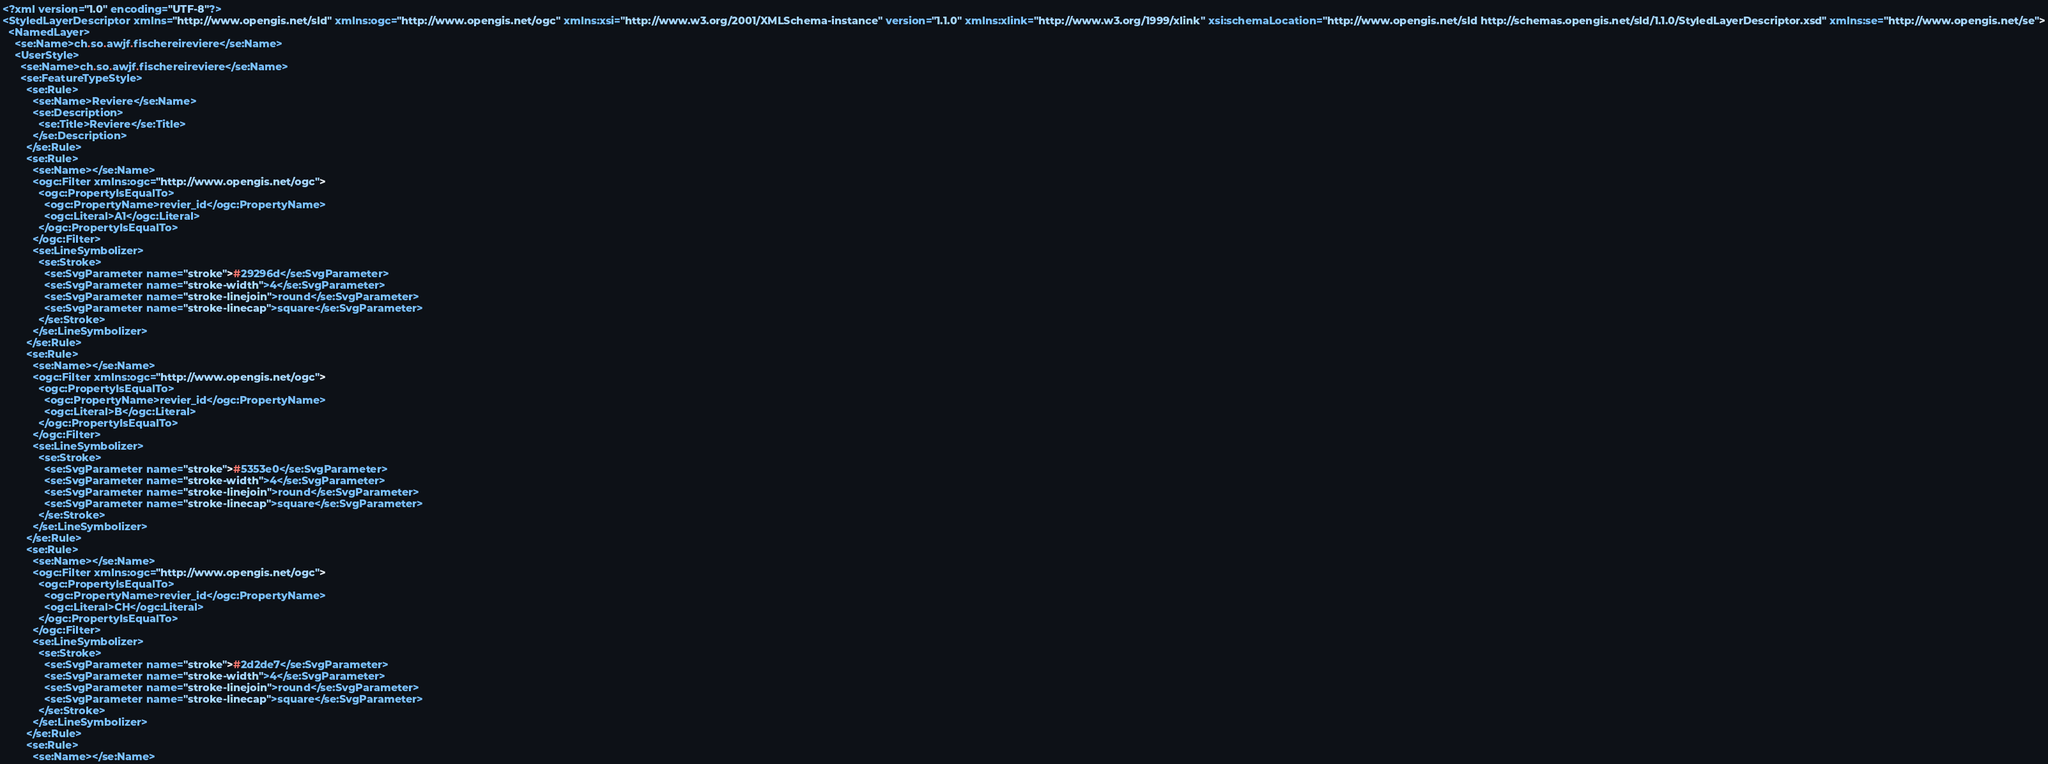<code> <loc_0><loc_0><loc_500><loc_500><_Scheme_><?xml version="1.0" encoding="UTF-8"?>
<StyledLayerDescriptor xmlns="http://www.opengis.net/sld" xmlns:ogc="http://www.opengis.net/ogc" xmlns:xsi="http://www.w3.org/2001/XMLSchema-instance" version="1.1.0" xmlns:xlink="http://www.w3.org/1999/xlink" xsi:schemaLocation="http://www.opengis.net/sld http://schemas.opengis.net/sld/1.1.0/StyledLayerDescriptor.xsd" xmlns:se="http://www.opengis.net/se">
  <NamedLayer>
    <se:Name>ch.so.awjf.fischereireviere</se:Name>
    <UserStyle>
      <se:Name>ch.so.awjf.fischereireviere</se:Name>
      <se:FeatureTypeStyle>
        <se:Rule>
          <se:Name>Reviere</se:Name>
          <se:Description>
            <se:Title>Reviere</se:Title>
          </se:Description>
        </se:Rule>
        <se:Rule>
          <se:Name></se:Name>
          <ogc:Filter xmlns:ogc="http://www.opengis.net/ogc">
            <ogc:PropertyIsEqualTo>
              <ogc:PropertyName>revier_id</ogc:PropertyName>
              <ogc:Literal>A1</ogc:Literal>
            </ogc:PropertyIsEqualTo>
          </ogc:Filter>
          <se:LineSymbolizer>
            <se:Stroke>
              <se:SvgParameter name="stroke">#29296d</se:SvgParameter>
              <se:SvgParameter name="stroke-width">4</se:SvgParameter>
              <se:SvgParameter name="stroke-linejoin">round</se:SvgParameter>
              <se:SvgParameter name="stroke-linecap">square</se:SvgParameter>
            </se:Stroke>
          </se:LineSymbolizer>
        </se:Rule>
        <se:Rule>
          <se:Name></se:Name>
          <ogc:Filter xmlns:ogc="http://www.opengis.net/ogc">
            <ogc:PropertyIsEqualTo>
              <ogc:PropertyName>revier_id</ogc:PropertyName>
              <ogc:Literal>B</ogc:Literal>
            </ogc:PropertyIsEqualTo>
          </ogc:Filter>
          <se:LineSymbolizer>
            <se:Stroke>
              <se:SvgParameter name="stroke">#5353e0</se:SvgParameter>
              <se:SvgParameter name="stroke-width">4</se:SvgParameter>
              <se:SvgParameter name="stroke-linejoin">round</se:SvgParameter>
              <se:SvgParameter name="stroke-linecap">square</se:SvgParameter>
            </se:Stroke>
          </se:LineSymbolizer>
        </se:Rule>
        <se:Rule>
          <se:Name></se:Name>
          <ogc:Filter xmlns:ogc="http://www.opengis.net/ogc">
            <ogc:PropertyIsEqualTo>
              <ogc:PropertyName>revier_id</ogc:PropertyName>
              <ogc:Literal>CH</ogc:Literal>
            </ogc:PropertyIsEqualTo>
          </ogc:Filter>
          <se:LineSymbolizer>
            <se:Stroke>
              <se:SvgParameter name="stroke">#2d2de7</se:SvgParameter>
              <se:SvgParameter name="stroke-width">4</se:SvgParameter>
              <se:SvgParameter name="stroke-linejoin">round</se:SvgParameter>
              <se:SvgParameter name="stroke-linecap">square</se:SvgParameter>
            </se:Stroke>
          </se:LineSymbolizer>
        </se:Rule>
        <se:Rule>
          <se:Name></se:Name></code> 